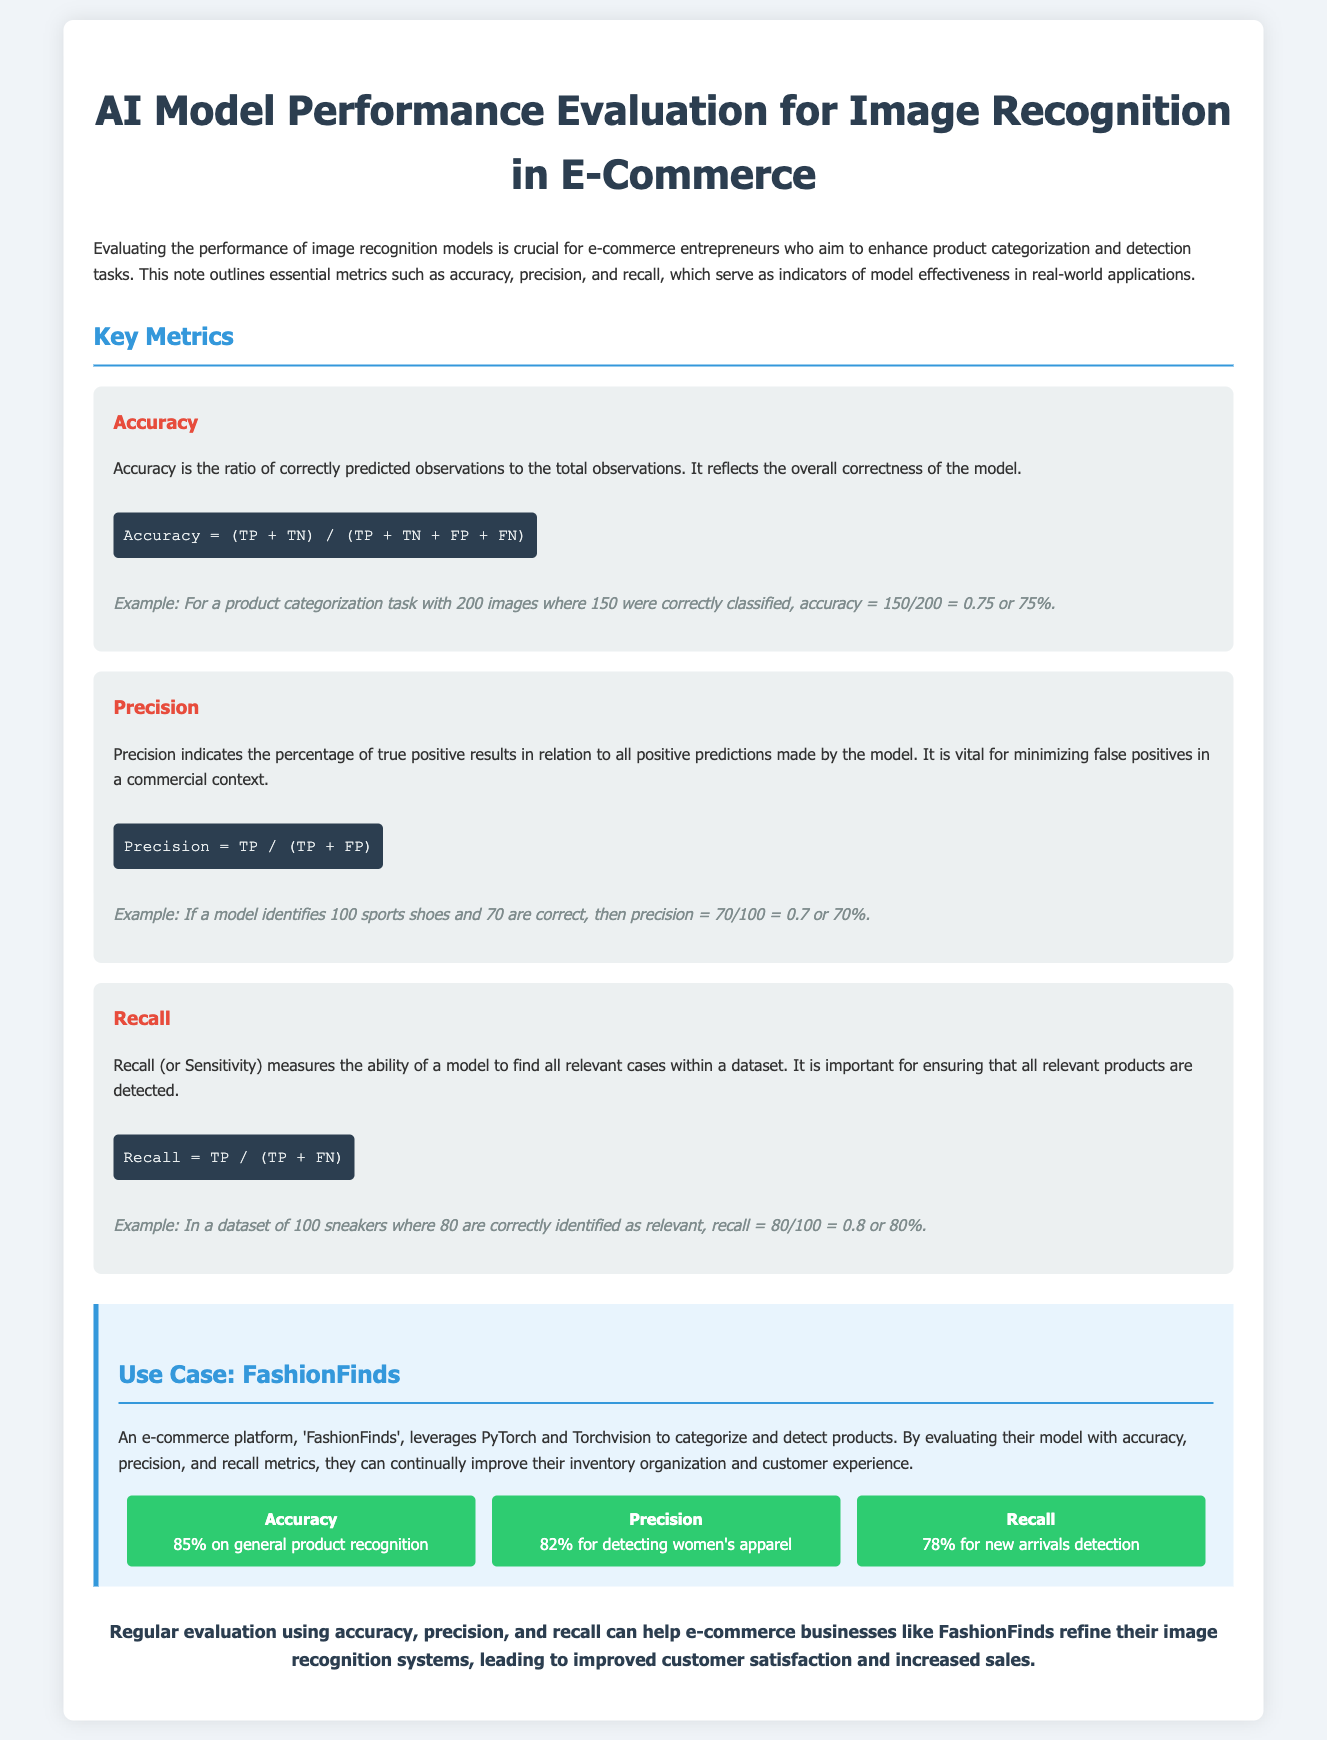What is the main topic of the document? The document discusses the evaluation of AI model performance in image recognition specifically for e-commerce.
Answer: AI Model Performance Evaluation for Image Recognition in E-Commerce What is the accuracy percentage for general product recognition? The accuracy for general product recognition is provided in the results section of the document.
Answer: 85% What formula is used to calculate precision? The formula for precision is stated within the section that describes precision.
Answer: Precision = TP / (TP + FP) What does recall measure in the context of this document? The document states that recall measures the ability of a model to find all relevant cases within a dataset, crucial for product detection.
Answer: Ability to find all relevant cases What is the precision percentage for detecting women's apparel? The document includes a specific precision metric for detecting women's apparel in its results section.
Answer: 82% What example is given for calculating accuracy? The document includes an example showing how accuracy is calculated using product categorization.
Answer: 150/200 = 0.75 or 75% How does FashionFinds use the model evaluation metrics? The document mentions that FashionFinds uses the metrics to improve their inventory organization and customer experience.
Answer: Improve inventory organization and customer experience What is the recall percentage for new arrivals detection? The results section of the document provides the recall percentage for new arrivals detection specifically.
Answer: 78% Why is precision important in an e-commerce context? The text indicates that precision is vital for minimizing false positives, important for commercial applications.
Answer: Minimizing false positives 